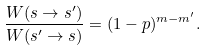<formula> <loc_0><loc_0><loc_500><loc_500>\frac { W ( { s } \rightarrow { s } ^ { \prime } ) } { W ( { s } ^ { \prime } \rightarrow { s } ) } = ( 1 - p ) ^ { m - m ^ { \prime } } .</formula> 